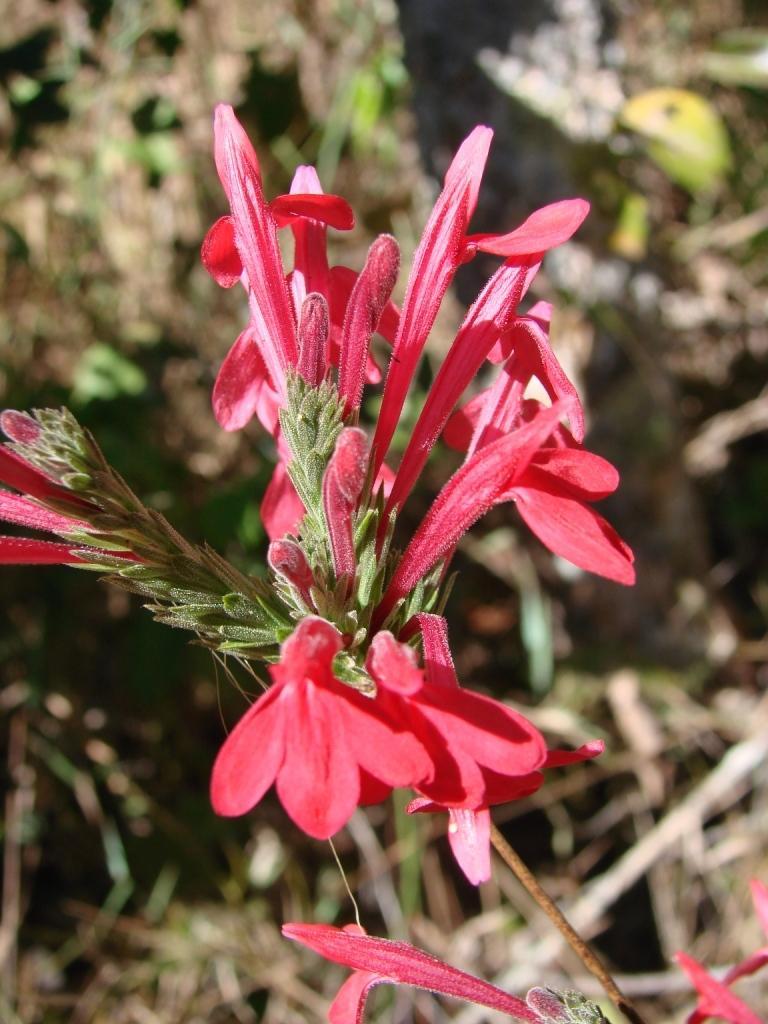How would you summarize this image in a sentence or two? In this image we can see a bunch of flowers and some buds to the stem of a plant. 